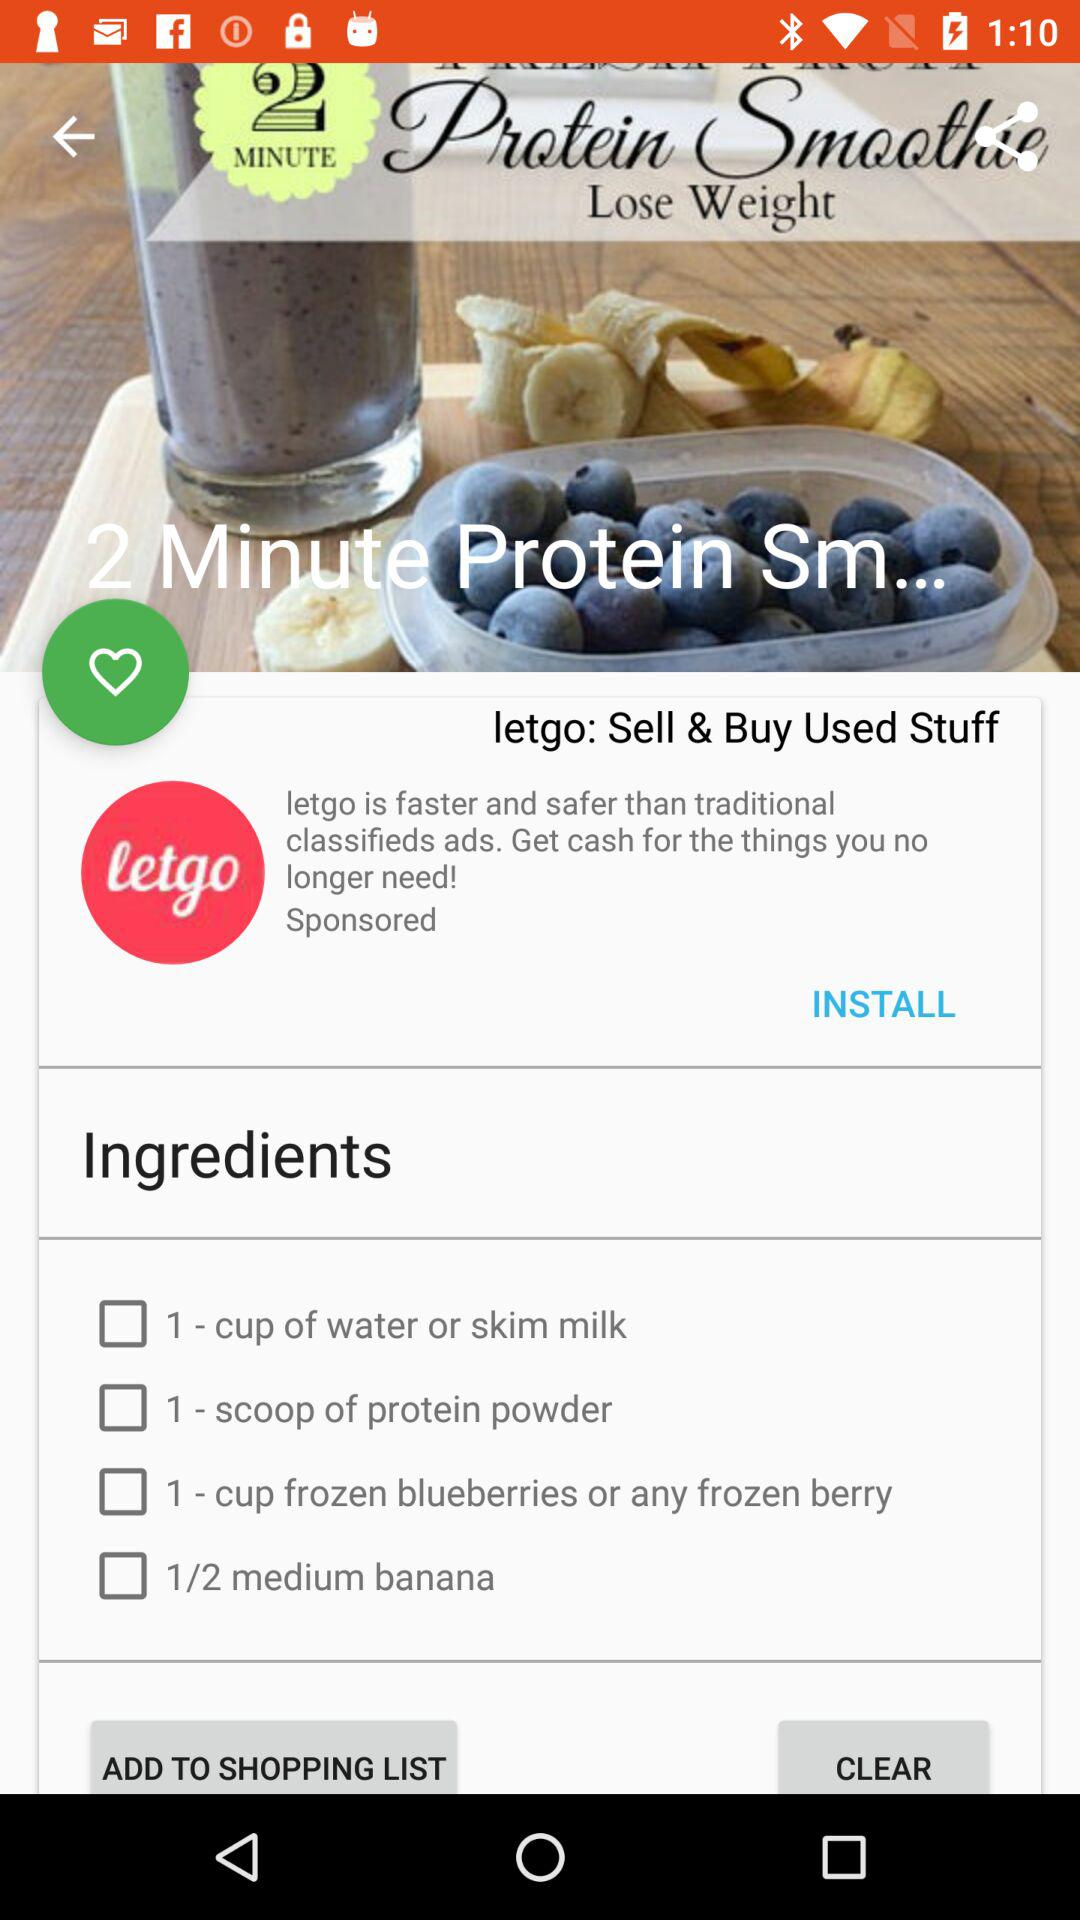How many blueberries are in the recipe?
Answer the question using a single word or phrase. 1 cup 